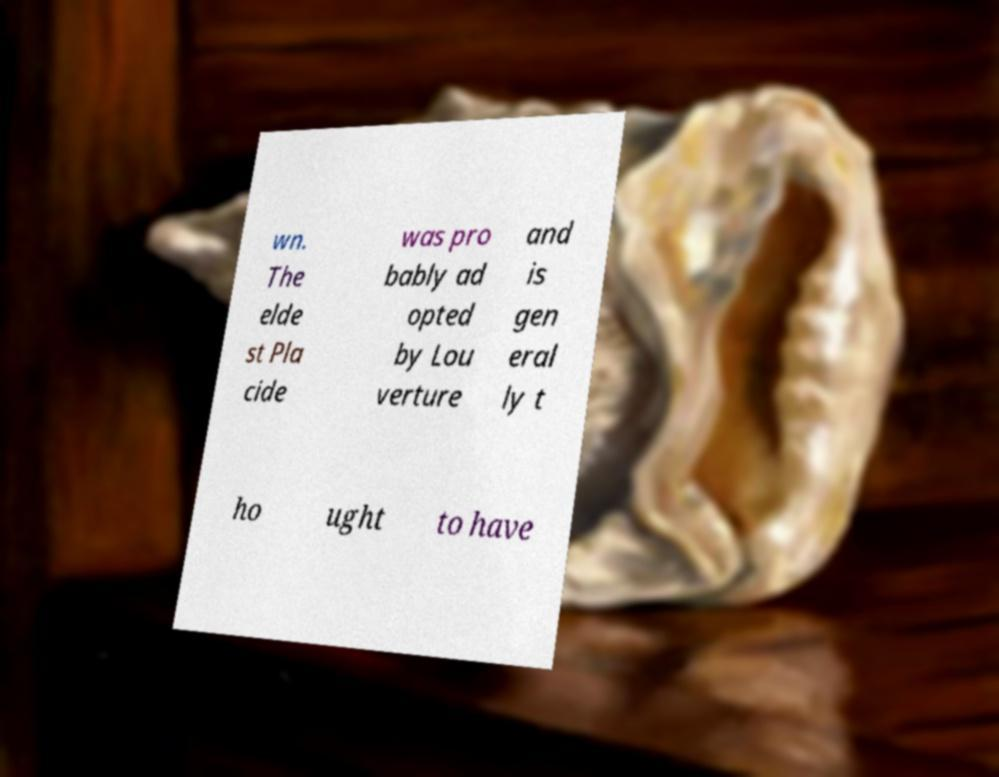Can you read and provide the text displayed in the image?This photo seems to have some interesting text. Can you extract and type it out for me? wn. The elde st Pla cide was pro bably ad opted by Lou verture and is gen eral ly t ho ught to have 